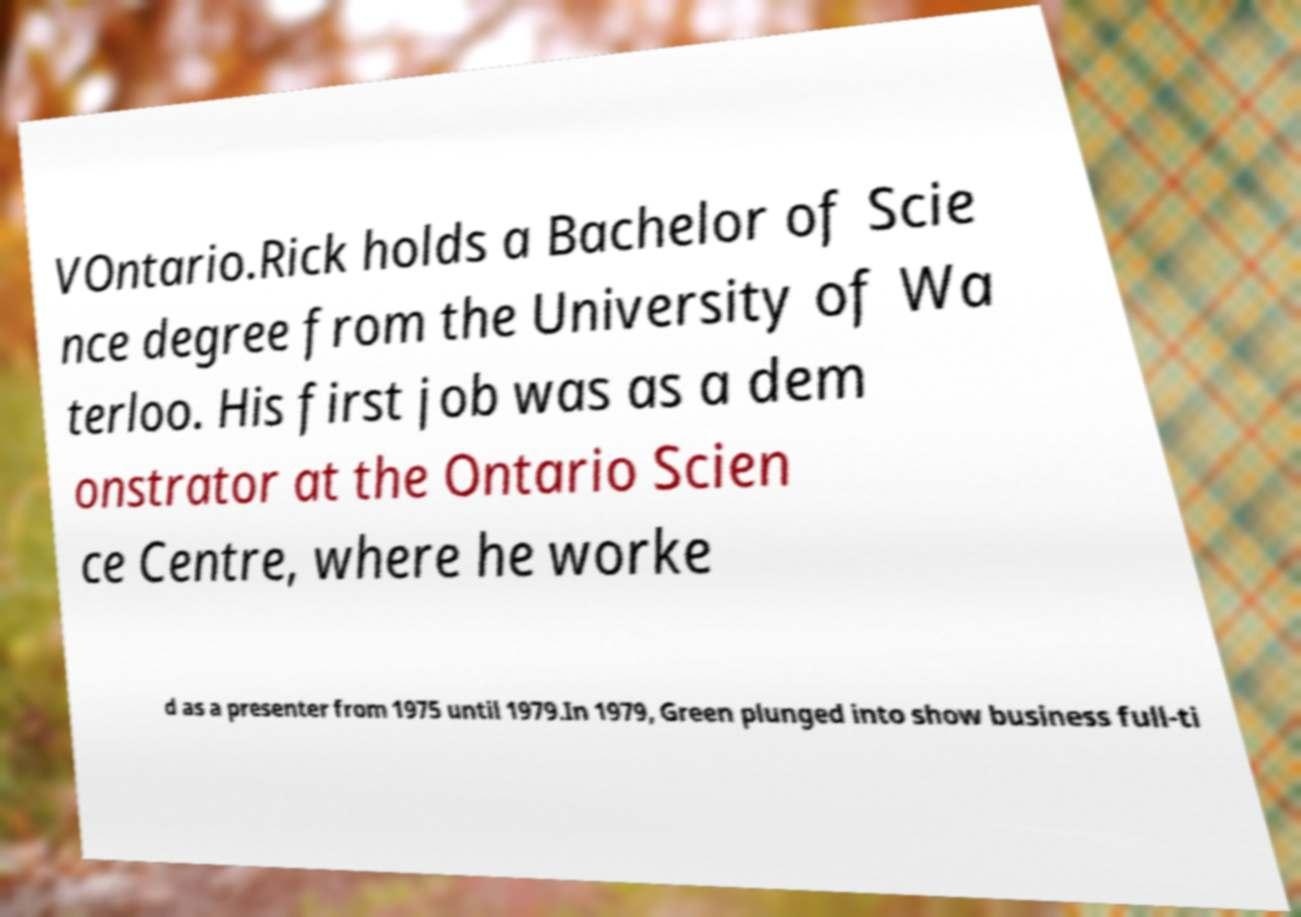There's text embedded in this image that I need extracted. Can you transcribe it verbatim? VOntario.Rick holds a Bachelor of Scie nce degree from the University of Wa terloo. His first job was as a dem onstrator at the Ontario Scien ce Centre, where he worke d as a presenter from 1975 until 1979.In 1979, Green plunged into show business full-ti 